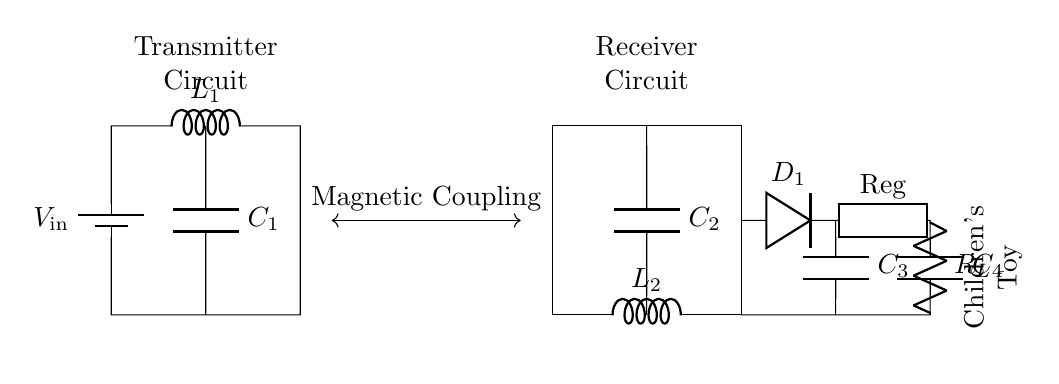What is the input voltage for this circuit? The input voltage is indicated as V_in in the diagram, which is shown connected to the battery element.
Answer: V_in What type of component is C_1? C_1 is labeled in the circuit as a capacitor, which is indicated by the ‘C’ symbol in the diagram.
Answer: Capacitor How many inductors are present in this circuit? There are two inductors shown in the circuit: L_1 for the transmitter side and L_2 for the receiver side.
Answer: Two What is the function of the diode D_1? The diode D_1 is used to rectify the AC signal produced during wireless power transfer, allowing only one direction of current flow to charge the capacitors and supply power to the load.
Answer: Rectification What is the purpose of the voltage regulator in this wireless charging circuit? The voltage regulator labeled as Reg ensures that the output voltage to the load remains stable, regardless of variations in input voltage or load current.
Answer: Voltage stabilization What is connected between the transmitter and receiver circuits? The component connecting both circuits is identified as "Magnetic Coupling", which represents the method used for wireless energy transfer.
Answer: Magnetic Coupling What is the load in this circuit? The load is indicated as R_L, which is shown as a resistor in the circuit representing the component powered by the wireless charging process.
Answer: Resistor 